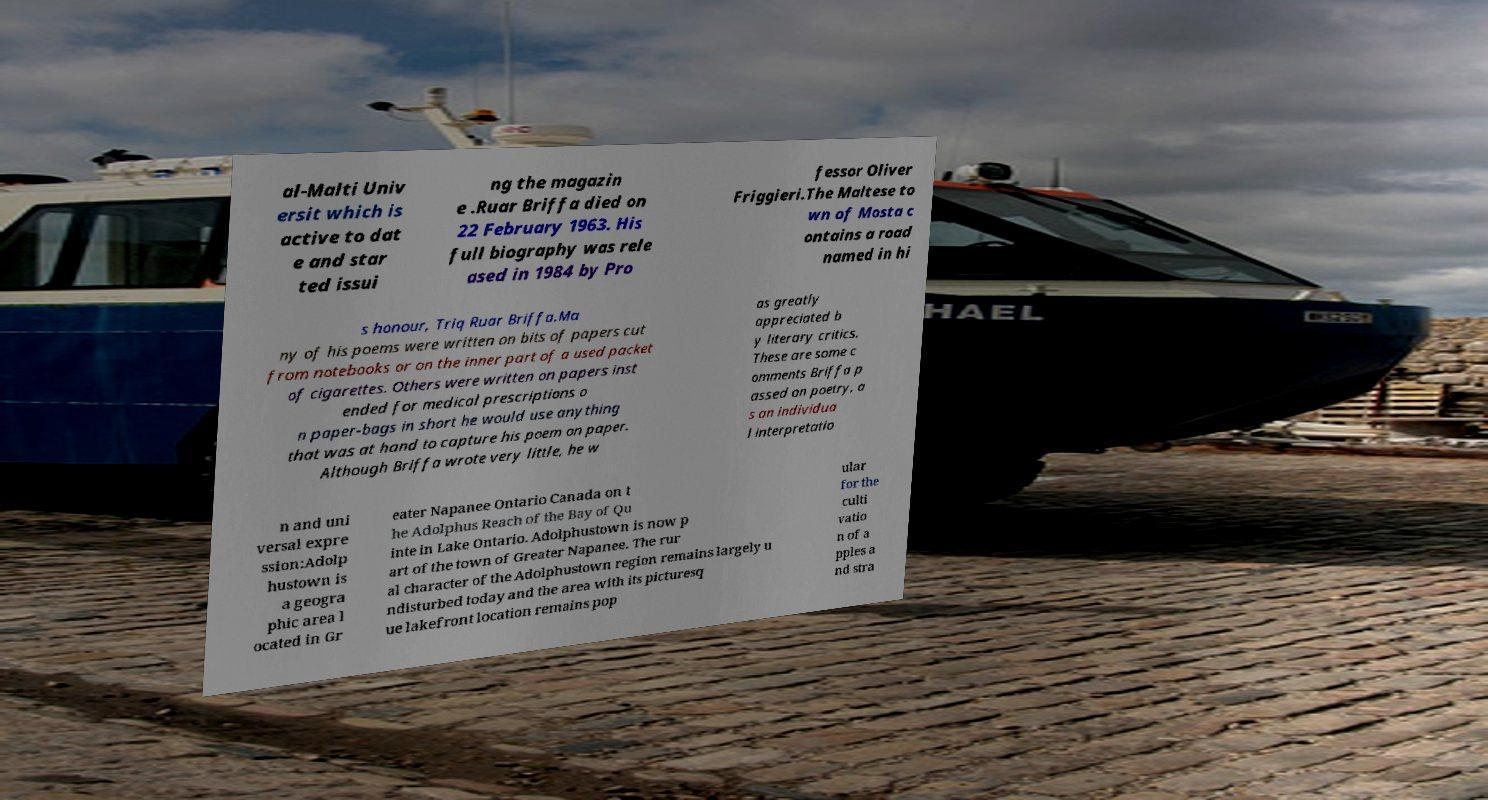For documentation purposes, I need the text within this image transcribed. Could you provide that? al-Malti Univ ersit which is active to dat e and star ted issui ng the magazin e .Ruar Briffa died on 22 February 1963. His full biography was rele ased in 1984 by Pro fessor Oliver Friggieri.The Maltese to wn of Mosta c ontains a road named in hi s honour, Triq Ruar Briffa.Ma ny of his poems were written on bits of papers cut from notebooks or on the inner part of a used packet of cigarettes. Others were written on papers inst ended for medical prescriptions o n paper-bags in short he would use anything that was at hand to capture his poem on paper. Although Briffa wrote very little, he w as greatly appreciated b y literary critics. These are some c omments Briffa p assed on poetry, a s an individua l interpretatio n and uni versal expre ssion:Adolp hustown is a geogra phic area l ocated in Gr eater Napanee Ontario Canada on t he Adolphus Reach of the Bay of Qu inte in Lake Ontario. Adolphustown is now p art of the town of Greater Napanee. The rur al character of the Adolphustown region remains largely u ndisturbed today and the area with its picturesq ue lakefront location remains pop ular for the culti vatio n of a pples a nd stra 